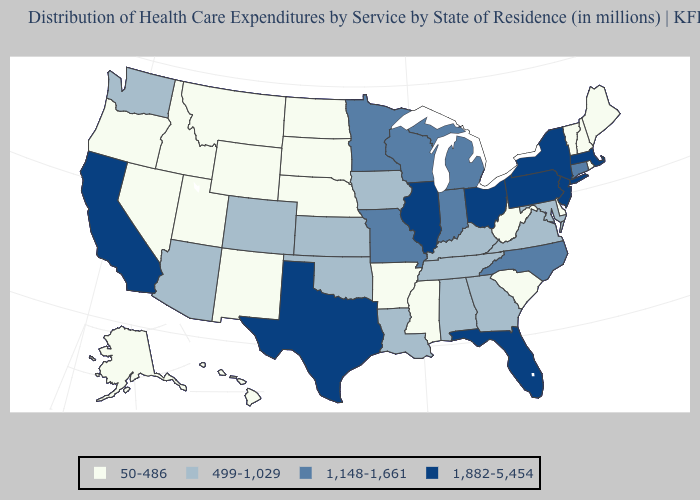Does Oregon have the lowest value in the West?
Short answer required. Yes. Among the states that border Vermont , which have the highest value?
Answer briefly. Massachusetts, New York. What is the value of Texas?
Answer briefly. 1,882-5,454. Does Indiana have the lowest value in the MidWest?
Concise answer only. No. Which states have the lowest value in the Northeast?
Keep it brief. Maine, New Hampshire, Rhode Island, Vermont. Which states have the lowest value in the USA?
Keep it brief. Alaska, Arkansas, Delaware, Hawaii, Idaho, Maine, Mississippi, Montana, Nebraska, Nevada, New Hampshire, New Mexico, North Dakota, Oregon, Rhode Island, South Carolina, South Dakota, Utah, Vermont, West Virginia, Wyoming. What is the highest value in states that border Nebraska?
Keep it brief. 1,148-1,661. Name the states that have a value in the range 1,882-5,454?
Give a very brief answer. California, Florida, Illinois, Massachusetts, New Jersey, New York, Ohio, Pennsylvania, Texas. Does the map have missing data?
Answer briefly. No. What is the value of Washington?
Quick response, please. 499-1,029. What is the value of Minnesota?
Short answer required. 1,148-1,661. Among the states that border West Virginia , which have the lowest value?
Write a very short answer. Kentucky, Maryland, Virginia. Is the legend a continuous bar?
Be succinct. No. Which states have the highest value in the USA?
Keep it brief. California, Florida, Illinois, Massachusetts, New Jersey, New York, Ohio, Pennsylvania, Texas. Which states hav the highest value in the South?
Give a very brief answer. Florida, Texas. 